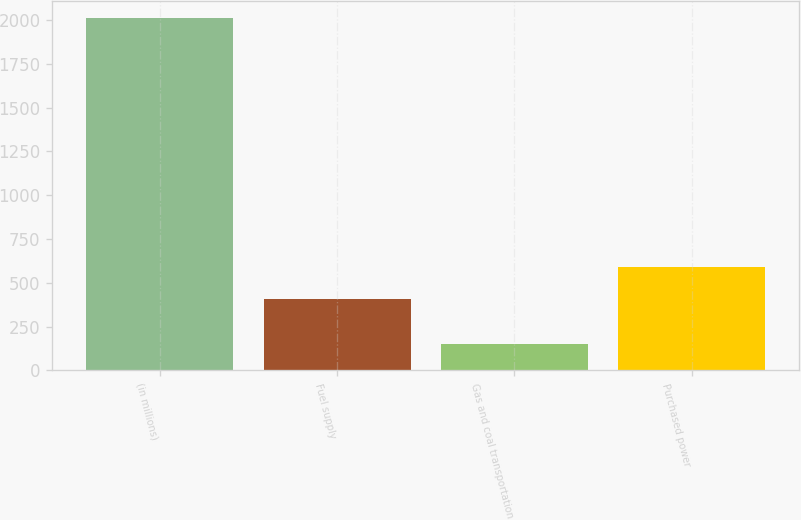<chart> <loc_0><loc_0><loc_500><loc_500><bar_chart><fcel>(in millions)<fcel>Fuel supply<fcel>Gas and coal transportation<fcel>Purchased power<nl><fcel>2011<fcel>405<fcel>152<fcel>590.9<nl></chart> 